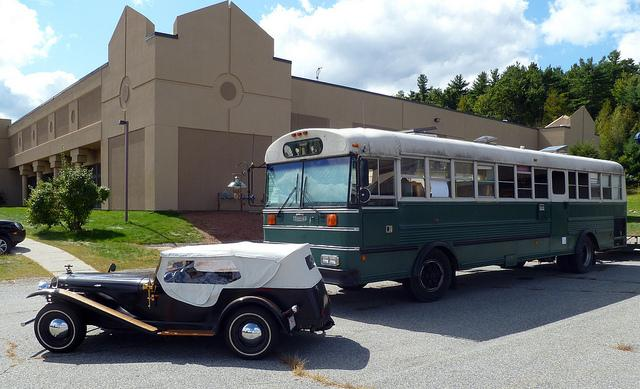Who is in danger of being struc? Please explain your reasoning. car. It is angled in front of the larger vehicle 